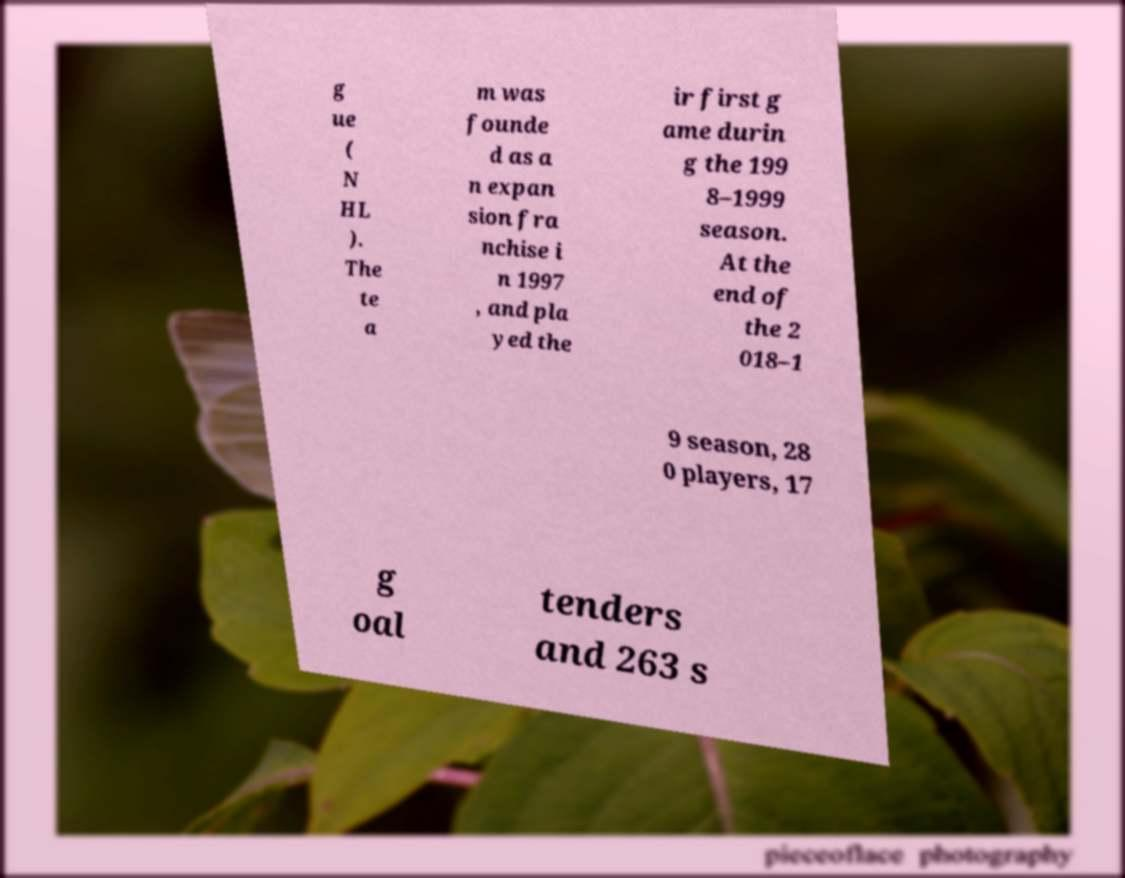I need the written content from this picture converted into text. Can you do that? g ue ( N HL ). The te a m was founde d as a n expan sion fra nchise i n 1997 , and pla yed the ir first g ame durin g the 199 8–1999 season. At the end of the 2 018–1 9 season, 28 0 players, 17 g oal tenders and 263 s 